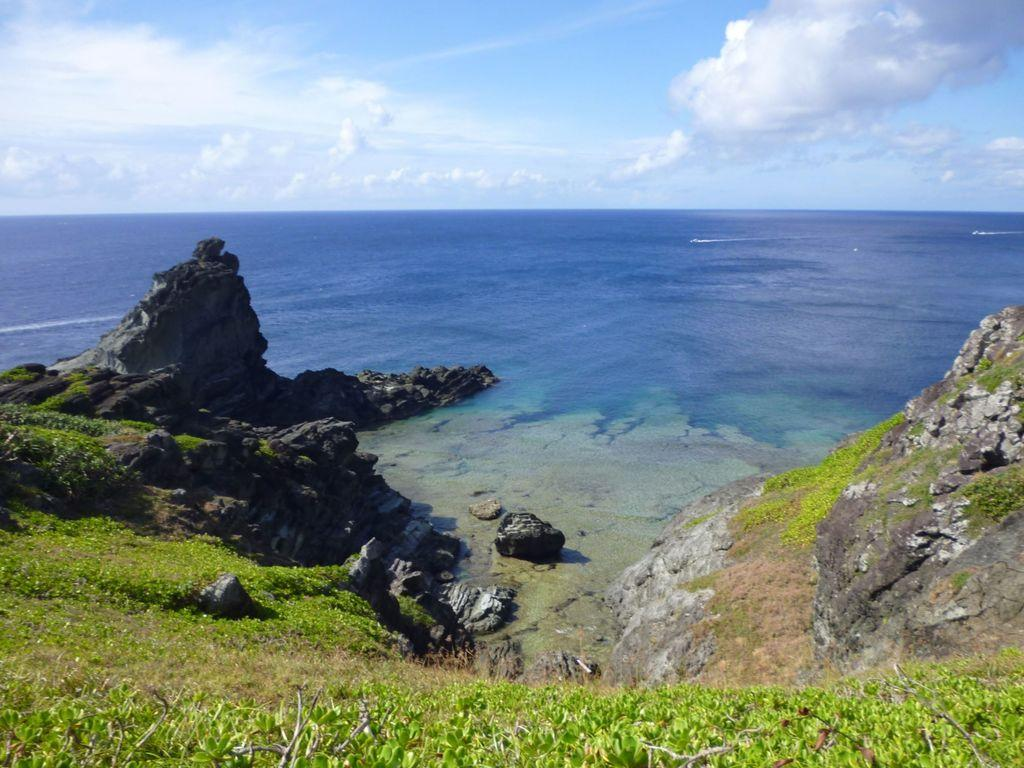What type of terrain is visible at the bottom of the image? There is grass on the ground at the bottom of the image. What other natural elements can be seen in the image? There are rocks and water visible in the image. What is visible at the top of the image? The sky is visible at the top of the image. What can be observed in the sky? Clouds are present in the sky. How many coils are wrapped around the celery in the image? There is no celery or coils present in the image. What type of balls are being used to play a game in the image? There is no game or balls present in the image. 